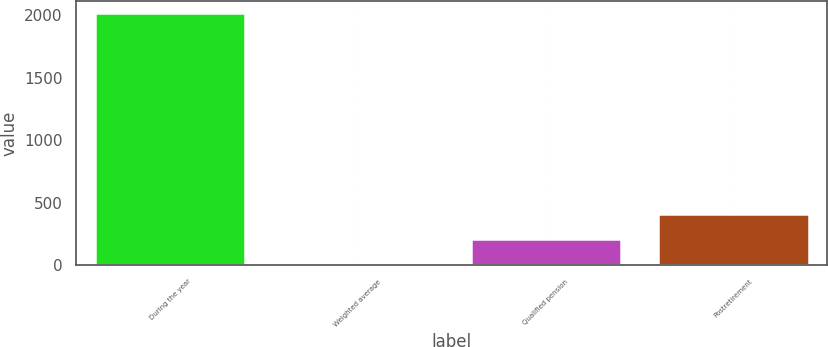Convert chart. <chart><loc_0><loc_0><loc_500><loc_500><bar_chart><fcel>During the year<fcel>Weighted average<fcel>Qualified pension<fcel>Postretirement<nl><fcel>2017<fcel>4.4<fcel>205.66<fcel>406.92<nl></chart> 